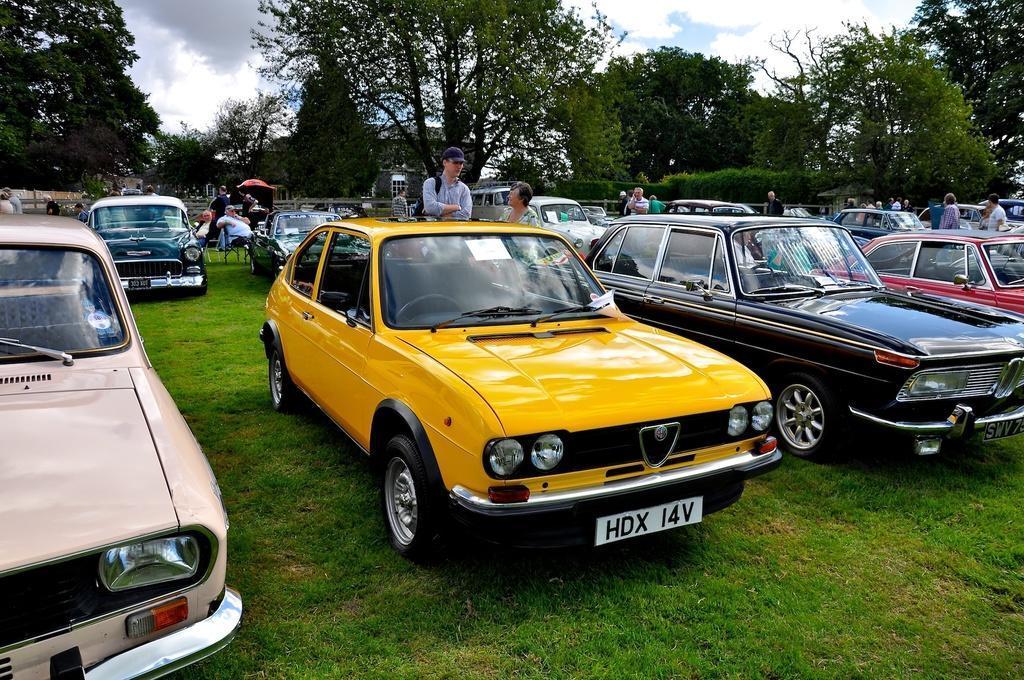Could you give a brief overview of what you see in this image? In this image I can see many vehicles are on the grass. To the side of these vehicles I can see the few people with different color dresses. I can see one person with the cap. In the background I can see many trees, clouds and the sky. 